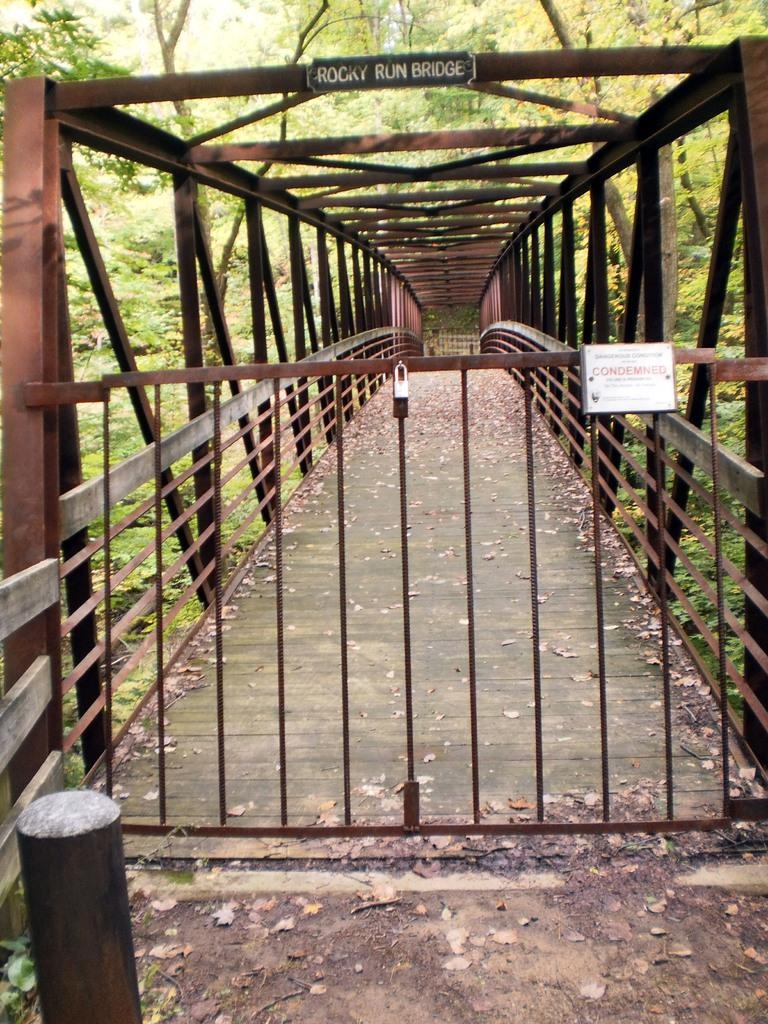What is the main structure in the center of the image? There is a bridge in the center of the image. What is located at the bottom of the image? There is a gate at the bottom of the image. What type of natural scenery can be seen in the background of the image? There are trees in the background of the image. What color is the sheet draped over the bed in the image? There is no bed or sheet present in the image; it features a bridge and a gate. Can you tell me how many power outlets are visible in the image? There are no power outlets visible in the image; it features a bridge, a gate, and trees. 